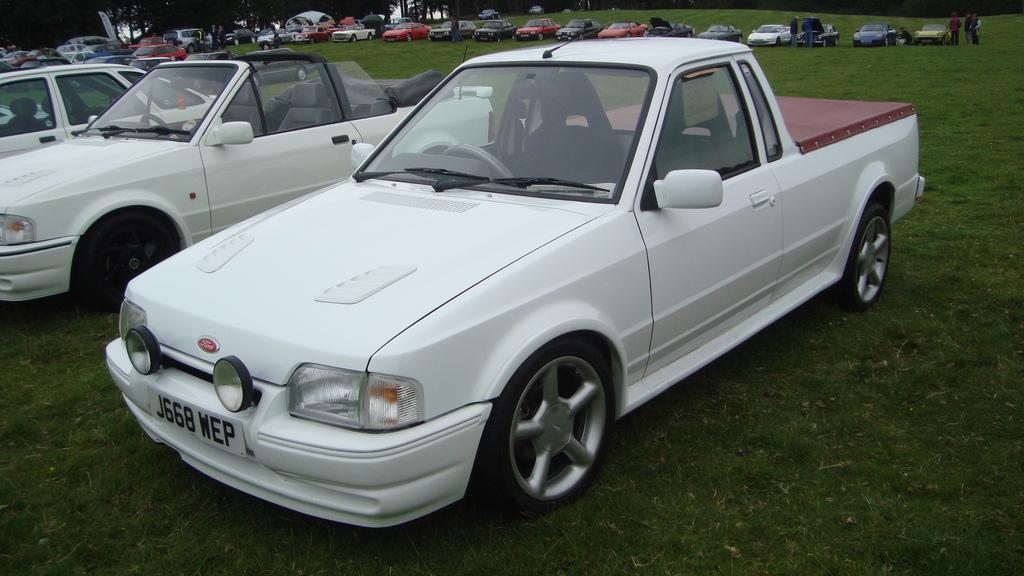Could you give a brief overview of what you see in this image? In the image I can see some cars which are parked on the ground and also I can see some people and some trees. 